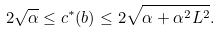Convert formula to latex. <formula><loc_0><loc_0><loc_500><loc_500>2 \sqrt { \alpha } \leq c ^ { * } ( b ) \leq 2 \sqrt { \alpha + \alpha ^ { 2 } L ^ { 2 } } .</formula> 